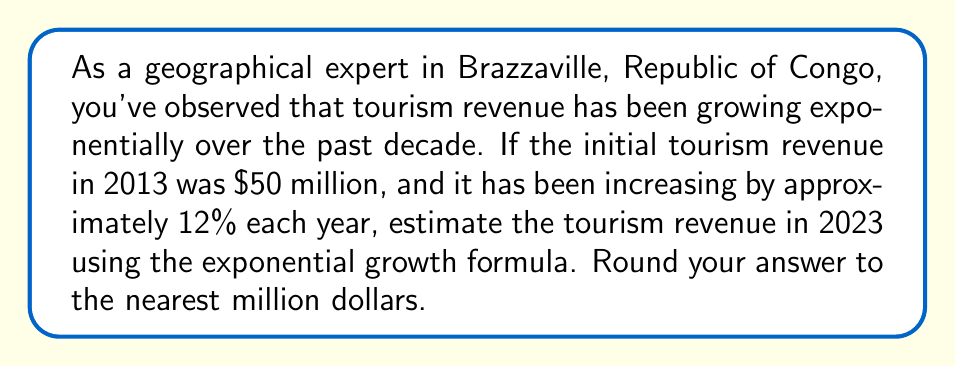Can you solve this math problem? To solve this problem, we'll use the exponential growth formula:

$$A = P(1 + r)^t$$

Where:
$A$ = Final amount
$P$ = Initial principal balance
$r$ = Annual growth rate (as a decimal)
$t$ = Number of years

Given:
$P = \$50$ million (initial revenue in 2013)
$r = 0.12$ (12% annual growth rate)
$t = 10$ years (from 2013 to 2023)

Let's plug these values into the formula:

$$A = 50(1 + 0.12)^{10}$$

Now, let's calculate step-by-step:

1. Calculate $(1 + 0.12)$:
   $1 + 0.12 = 1.12$

2. Calculate $(1.12)^{10}$:
   $$(1.12)^{10} \approx 3.1058$$

3. Multiply the result by the initial amount:
   $$50 \times 3.1058 \approx 155.29$$

4. Round to the nearest million:
   $155.29$ million rounds to $155$ million

Therefore, the estimated tourism revenue in 2023 is approximately $155 million.
Answer: $155 million 